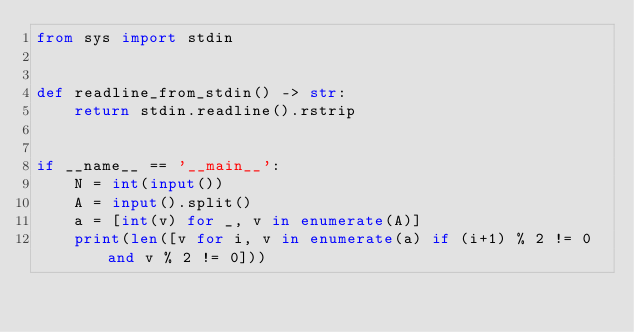Convert code to text. <code><loc_0><loc_0><loc_500><loc_500><_Python_>from sys import stdin


def readline_from_stdin() -> str:
    return stdin.readline().rstrip


if __name__ == '__main__':
    N = int(input())
    A = input().split()
    a = [int(v) for _, v in enumerate(A)]
    print(len([v for i, v in enumerate(a) if (i+1) % 2 != 0 and v % 2 != 0]))
</code> 